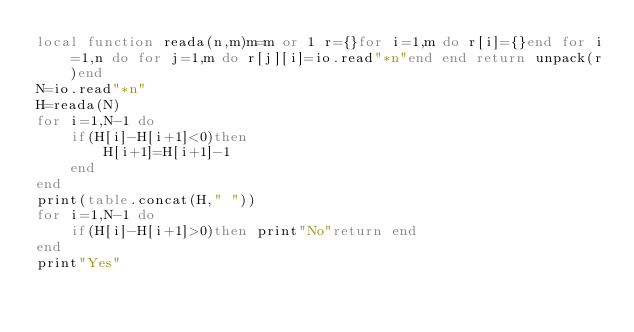<code> <loc_0><loc_0><loc_500><loc_500><_Lua_>local function reada(n,m)m=m or 1 r={}for i=1,m do r[i]={}end for i=1,n do for j=1,m do r[j][i]=io.read"*n"end end return unpack(r)end
N=io.read"*n"
H=reada(N)
for i=1,N-1 do
	if(H[i]-H[i+1]<0)then
		H[i+1]=H[i+1]-1
	end
end
print(table.concat(H," "))
for i=1,N-1 do
	if(H[i]-H[i+1]>0)then print"No"return end
end
print"Yes"
</code> 